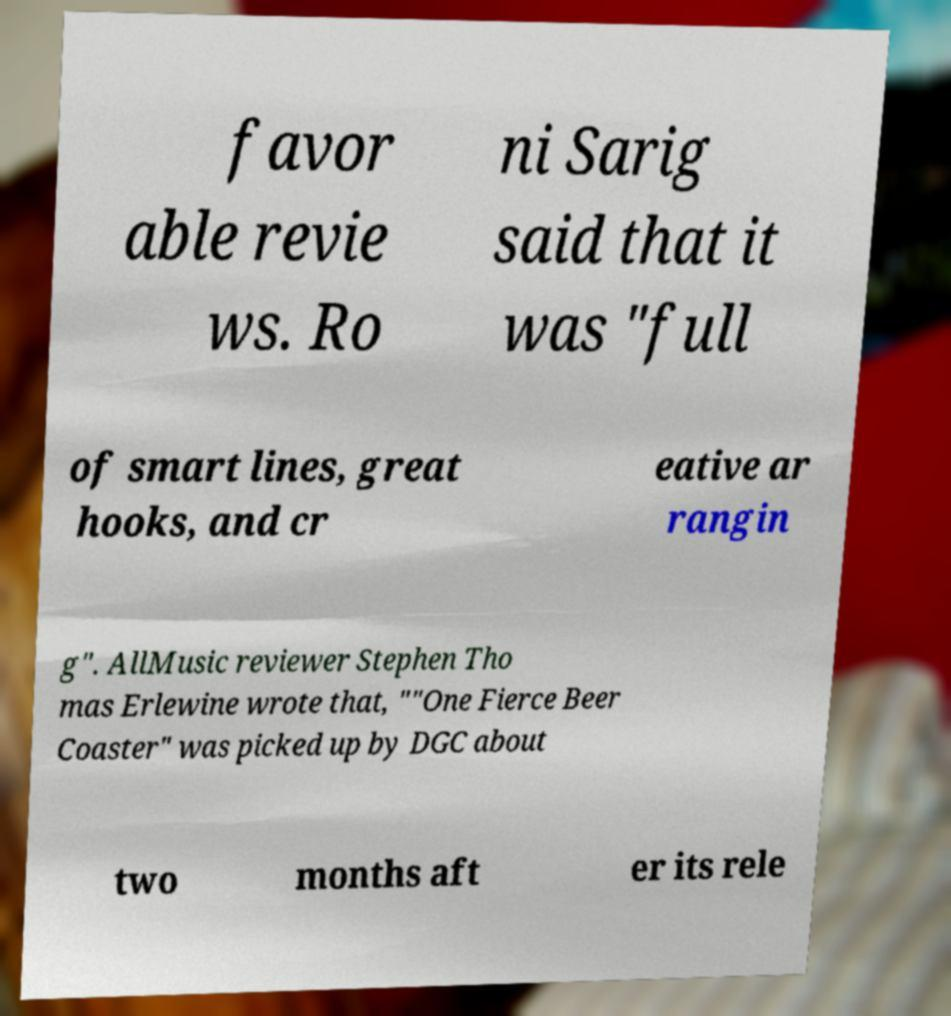I need the written content from this picture converted into text. Can you do that? favor able revie ws. Ro ni Sarig said that it was "full of smart lines, great hooks, and cr eative ar rangin g". AllMusic reviewer Stephen Tho mas Erlewine wrote that, ""One Fierce Beer Coaster" was picked up by DGC about two months aft er its rele 